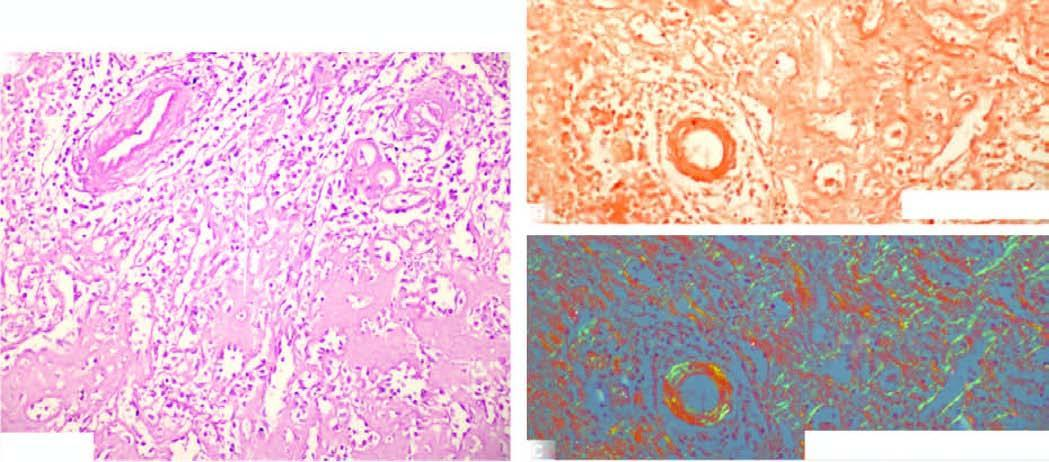what does b, congo red staining show as seen by red-pink colour?
Answer the question using a single word or phrase. Congophilia 